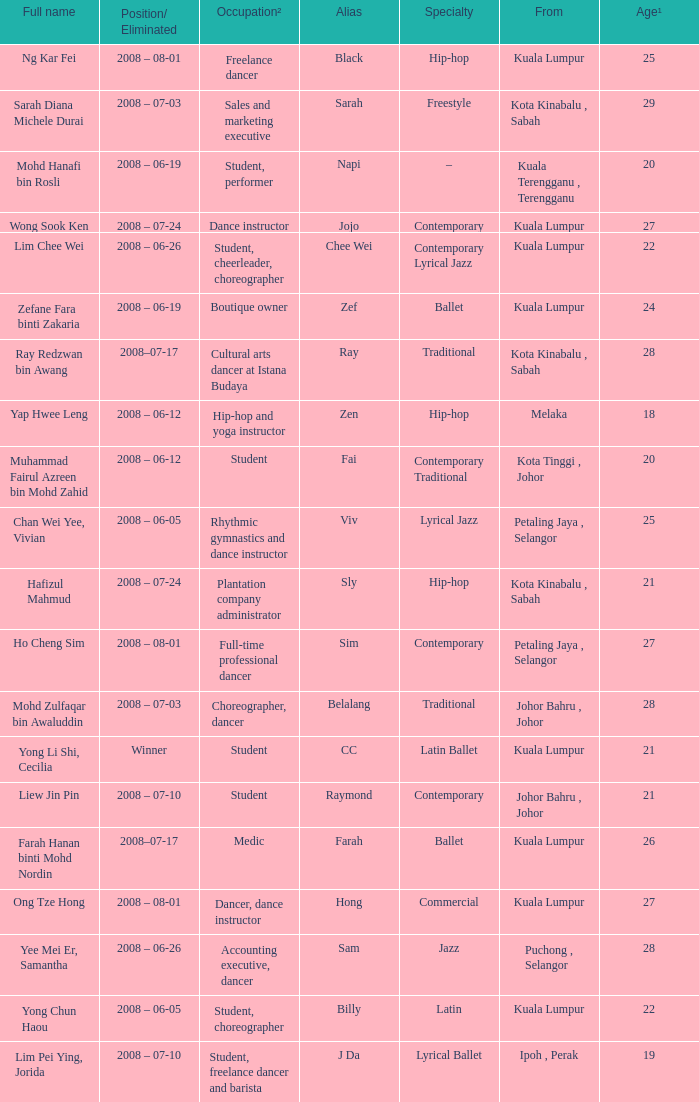What is Position/ Eliminated, when From is "Kuala Lumpur", and when Specialty is "Contemporary Lyrical Jazz"? 2008 – 06-26. 